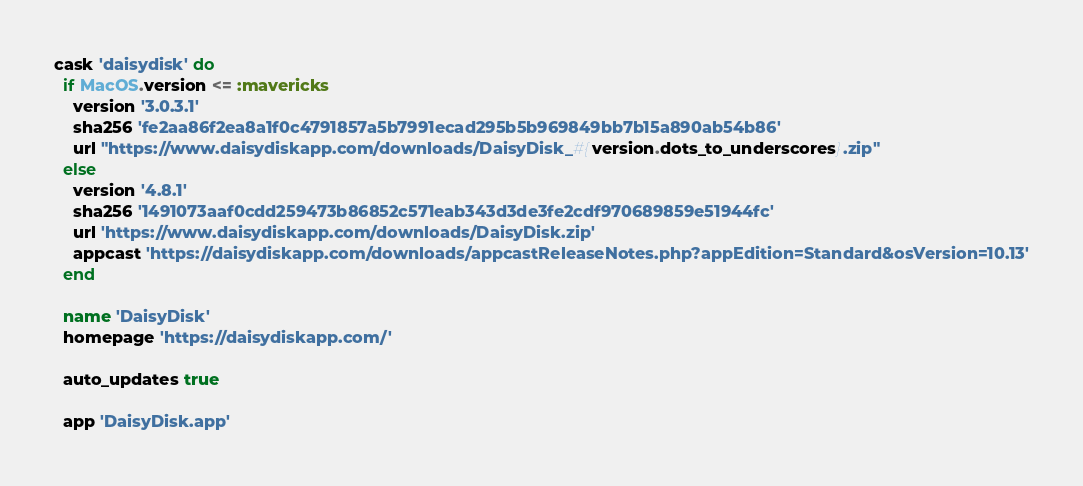Convert code to text. <code><loc_0><loc_0><loc_500><loc_500><_Ruby_>cask 'daisydisk' do
  if MacOS.version <= :mavericks
    version '3.0.3.1'
    sha256 'fe2aa86f2ea8a1f0c4791857a5b7991ecad295b5b969849bb7b15a890ab54b86'
    url "https://www.daisydiskapp.com/downloads/DaisyDisk_#{version.dots_to_underscores}.zip"
  else
    version '4.8.1'
    sha256 '1491073aaf0cdd259473b86852c571eab343d3de3fe2cdf970689859e51944fc'
    url 'https://www.daisydiskapp.com/downloads/DaisyDisk.zip'
    appcast 'https://daisydiskapp.com/downloads/appcastReleaseNotes.php?appEdition=Standard&osVersion=10.13'
  end

  name 'DaisyDisk'
  homepage 'https://daisydiskapp.com/'

  auto_updates true

  app 'DaisyDisk.app'
</code> 